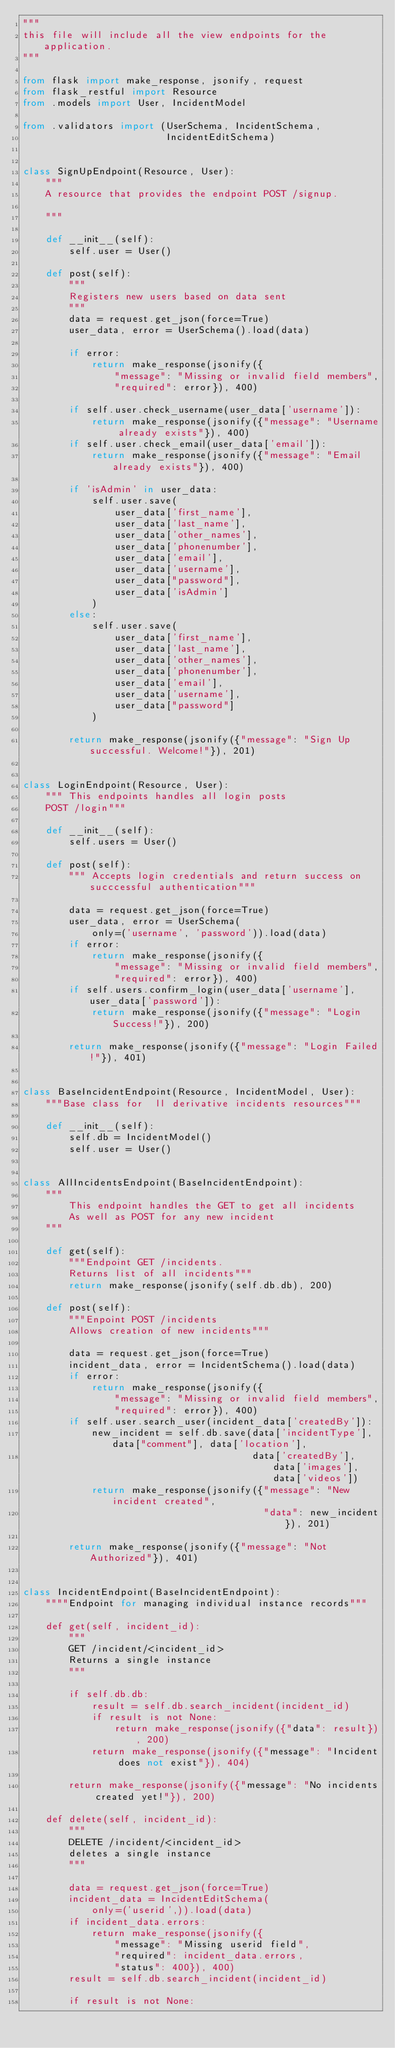Convert code to text. <code><loc_0><loc_0><loc_500><loc_500><_Python_>"""
this file will include all the view endpoints for the application.
"""

from flask import make_response, jsonify, request
from flask_restful import Resource
from .models import User, IncidentModel

from .validators import (UserSchema, IncidentSchema,
                         IncidentEditSchema)


class SignUpEndpoint(Resource, User):
    """
    A resource that provides the endpoint POST /signup.

    """

    def __init__(self):
        self.user = User()

    def post(self):
        """
        Registers new users based on data sent
        """
        data = request.get_json(force=True)
        user_data, error = UserSchema().load(data)

        if error:
            return make_response(jsonify({
                "message": "Missing or invalid field members",
                "required": error}), 400)

        if self.user.check_username(user_data['username']):
            return make_response(jsonify({"message": "Username already exists"}), 400)
        if self.user.check_email(user_data['email']):
            return make_response(jsonify({"message": "Email already exists"}), 400)

        if 'isAdmin' in user_data:
            self.user.save(
                user_data['first_name'],
                user_data['last_name'],
                user_data['other_names'],
                user_data['phonenumber'],
                user_data['email'],
                user_data['username'],
                user_data["password"],
                user_data['isAdmin']
            )
        else:
            self.user.save(
                user_data['first_name'],
                user_data['last_name'],
                user_data['other_names'],
                user_data['phonenumber'],
                user_data['email'],
                user_data['username'],
                user_data["password"]
            )

        return make_response(jsonify({"message": "Sign Up successful. Welcome!"}), 201)


class LoginEndpoint(Resource, User):
    """ This endpoints handles all login posts
    POST /login"""

    def __init__(self):
        self.users = User()

    def post(self):
        """ Accepts login credentials and return success on succcessful authentication"""

        data = request.get_json(force=True)
        user_data, error = UserSchema(
            only=('username', 'password')).load(data)
        if error:
            return make_response(jsonify({
                "message": "Missing or invalid field members",
                "required": error}), 400)
        if self.users.confirm_login(user_data['username'], user_data['password']):
            return make_response(jsonify({"message": "Login Success!"}), 200)

        return make_response(jsonify({"message": "Login Failed!"}), 401)


class BaseIncidentEndpoint(Resource, IncidentModel, User):
    """Base class for  ll derivative incidents resources"""

    def __init__(self):
        self.db = IncidentModel()
        self.user = User()


class AllIncidentsEndpoint(BaseIncidentEndpoint):
    """
        This endpoint handles the GET to get all incidents
        As well as POST for any new incident
    """

    def get(self):
        """Endpoint GET /incidents.
        Returns list of all incidents"""
        return make_response(jsonify(self.db.db), 200)

    def post(self):
        """Enpoint POST /incidents
        Allows creation of new incidents"""

        data = request.get_json(force=True)
        incident_data, error = IncidentSchema().load(data)
        if error:
            return make_response(jsonify({
                "message": "Missing or invalid field members",
                "required": error}), 400)
        if self.user.search_user(incident_data['createdBy']):
            new_incident = self.db.save(data['incidentType'], data["comment"], data['location'],
                                        data['createdBy'], data['images'], data['videos'])
            return make_response(jsonify({"message": "New incident created",
                                          "data": new_incident}), 201)

        return make_response(jsonify({"message": "Not Authorized"}), 401)


class IncidentEndpoint(BaseIncidentEndpoint):
    """"Endpoint for managing individual instance records"""

    def get(self, incident_id):
        """
        GET /incident/<incident_id>
        Returns a single instance
        """

        if self.db.db:
            result = self.db.search_incident(incident_id)
            if result is not None:
                return make_response(jsonify({"data": result}), 200)
            return make_response(jsonify({"message": "Incident does not exist"}), 404)

        return make_response(jsonify({"message": "No incidents created yet!"}), 200)

    def delete(self, incident_id):
        """
        DELETE /incident/<incident_id>
        deletes a single instance
        """

        data = request.get_json(force=True)
        incident_data = IncidentEditSchema(
            only=('userid',)).load(data)
        if incident_data.errors:
            return make_response(jsonify({
                "message": "Missing userid field",
                "required": incident_data.errors,
                "status": 400}), 400)
        result = self.db.search_incident(incident_id)

        if result is not None:</code> 